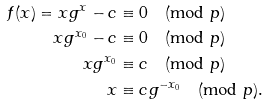Convert formula to latex. <formula><loc_0><loc_0><loc_500><loc_500>f ( x ) = x g ^ { x } - c & \equiv 0 \pmod { p } \\ x g ^ { x _ { 0 } } - c & \equiv 0 \pmod { p } \\ x g ^ { x _ { 0 } } & \equiv c \pmod { p } \\ x & \equiv c g ^ { - x _ { 0 } } \pmod { p } .</formula> 